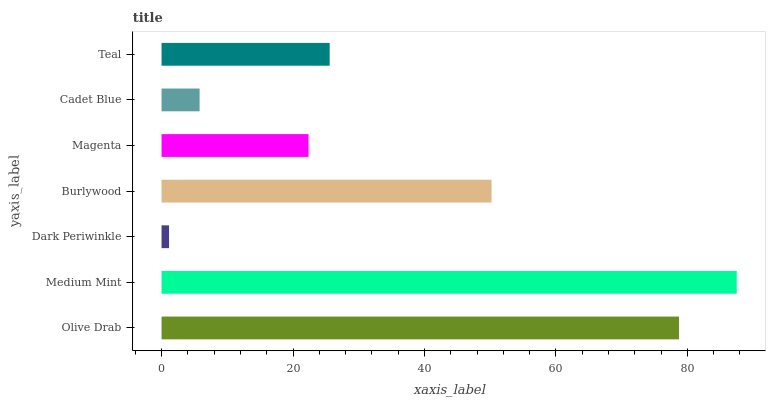Is Dark Periwinkle the minimum?
Answer yes or no. Yes. Is Medium Mint the maximum?
Answer yes or no. Yes. Is Medium Mint the minimum?
Answer yes or no. No. Is Dark Periwinkle the maximum?
Answer yes or no. No. Is Medium Mint greater than Dark Periwinkle?
Answer yes or no. Yes. Is Dark Periwinkle less than Medium Mint?
Answer yes or no. Yes. Is Dark Periwinkle greater than Medium Mint?
Answer yes or no. No. Is Medium Mint less than Dark Periwinkle?
Answer yes or no. No. Is Teal the high median?
Answer yes or no. Yes. Is Teal the low median?
Answer yes or no. Yes. Is Olive Drab the high median?
Answer yes or no. No. Is Dark Periwinkle the low median?
Answer yes or no. No. 